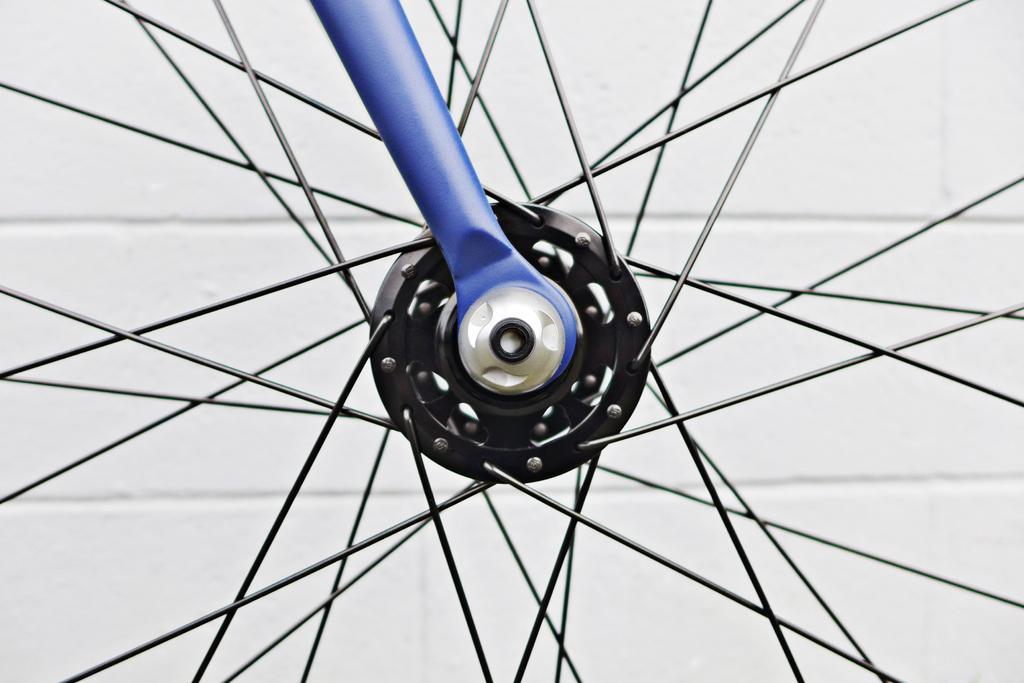How would you summarize this image in a sentence or two? In this picture we can see a wheel which is truncated, rod and in the background we can see the wall. 